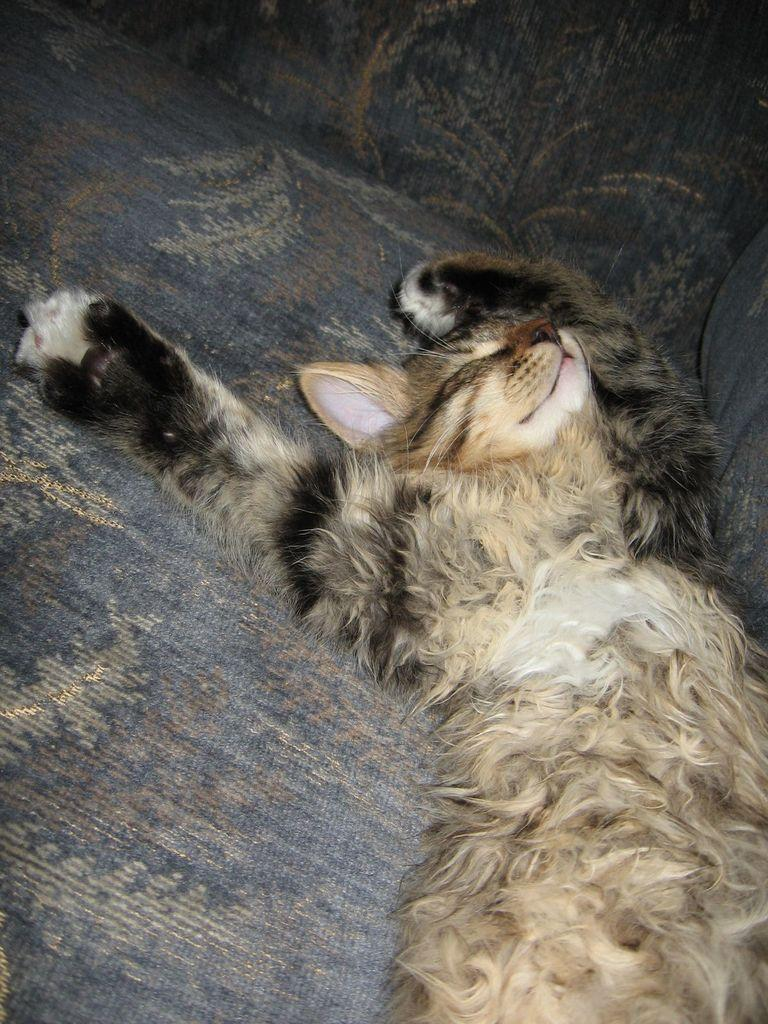What type of animal is present in the image? There is a cat in the image. What is the cat doing in the image? The cat is sleeping. Where is the cat located in the image? The cat is on a couch. How many brushes can be seen in the image? There are no brushes present in the image. What type of toys can be seen in the image? There are no toys present in the image. 